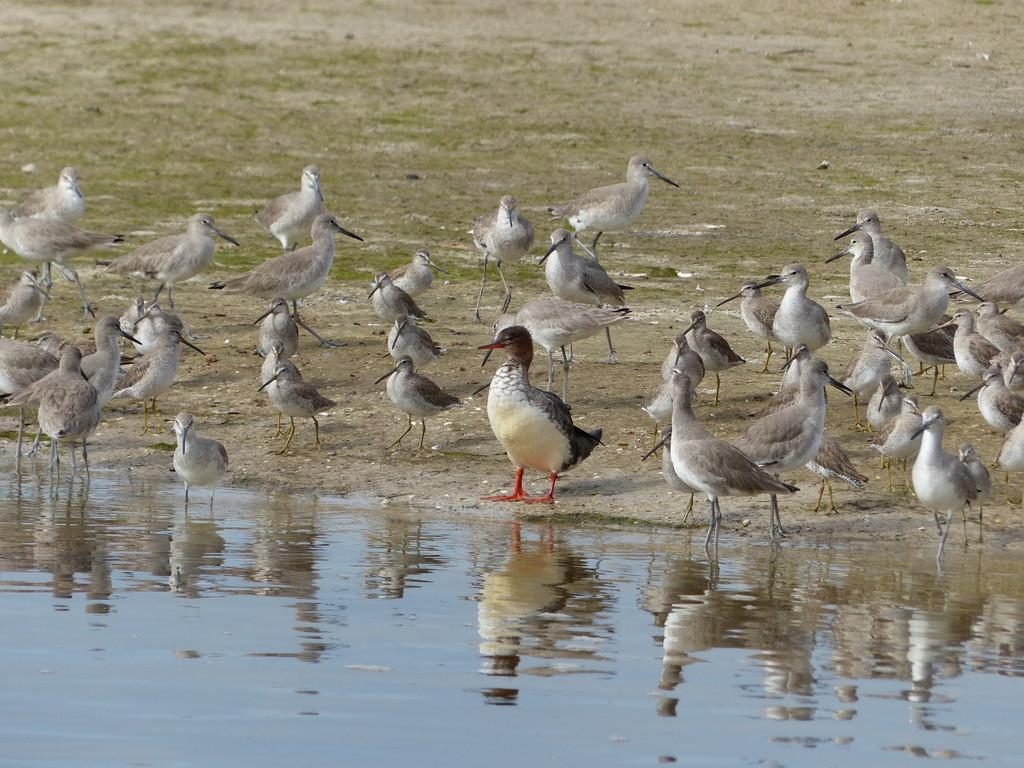What is visible in the image? There is water and a group of birds on the ground visible in the image. Can you describe the birds in the image? The birds are on the ground in the image. What is the primary element in the image? Water is the primary element visible in the image. What type of food is the group of birds eating in the image? There is no food visible in the image; it only shows a group of birds on the ground and water. What is the income level of the birds in the image? There is no information about the income level of the birds in the image, as birds do not have income. 